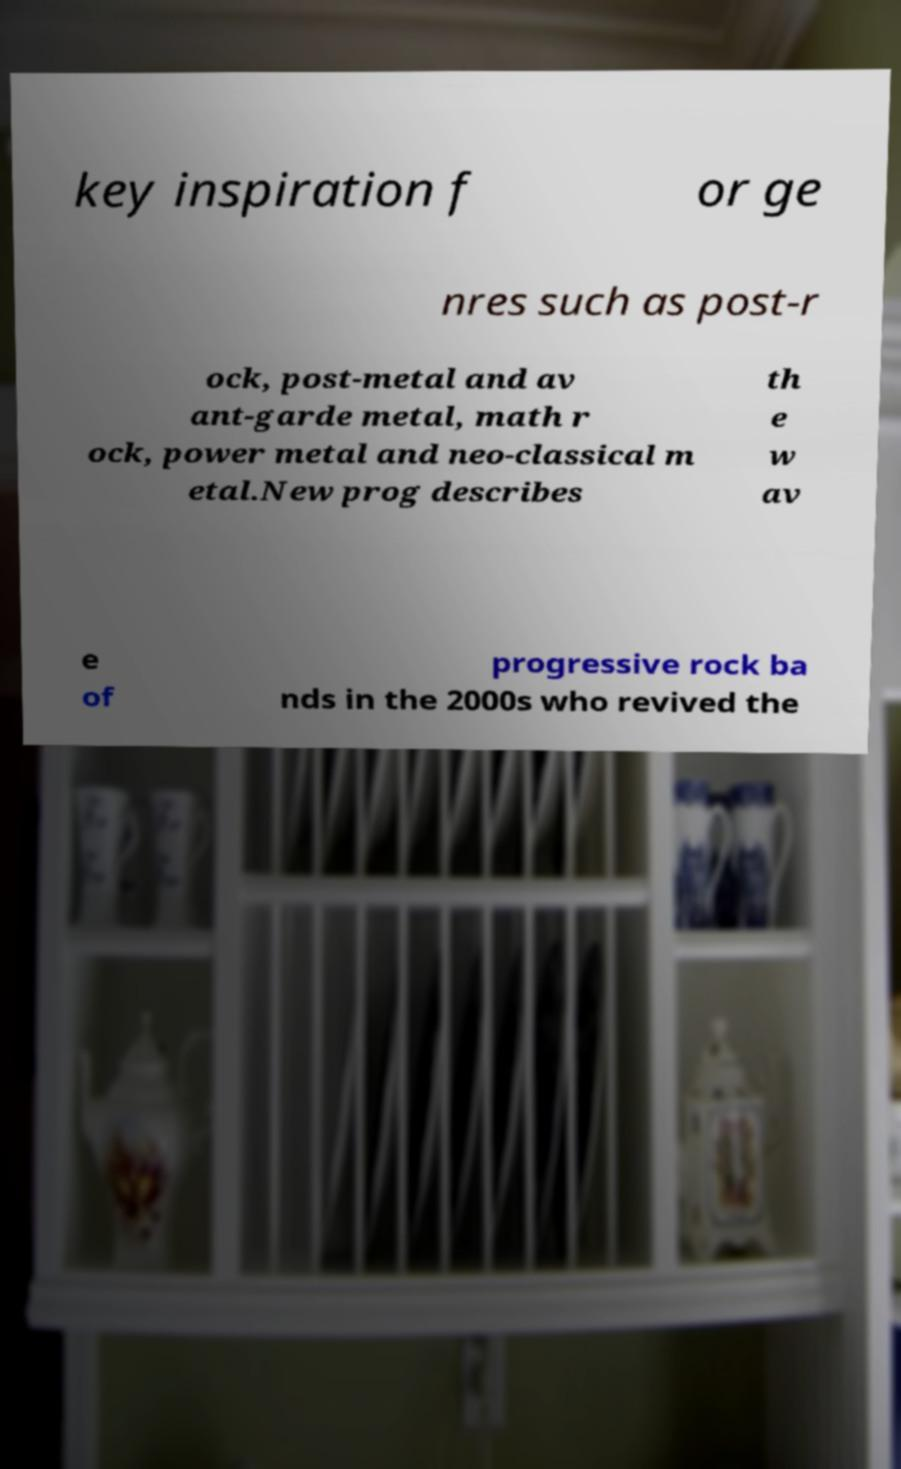Please read and relay the text visible in this image. What does it say? key inspiration f or ge nres such as post-r ock, post-metal and av ant-garde metal, math r ock, power metal and neo-classical m etal.New prog describes th e w av e of progressive rock ba nds in the 2000s who revived the 